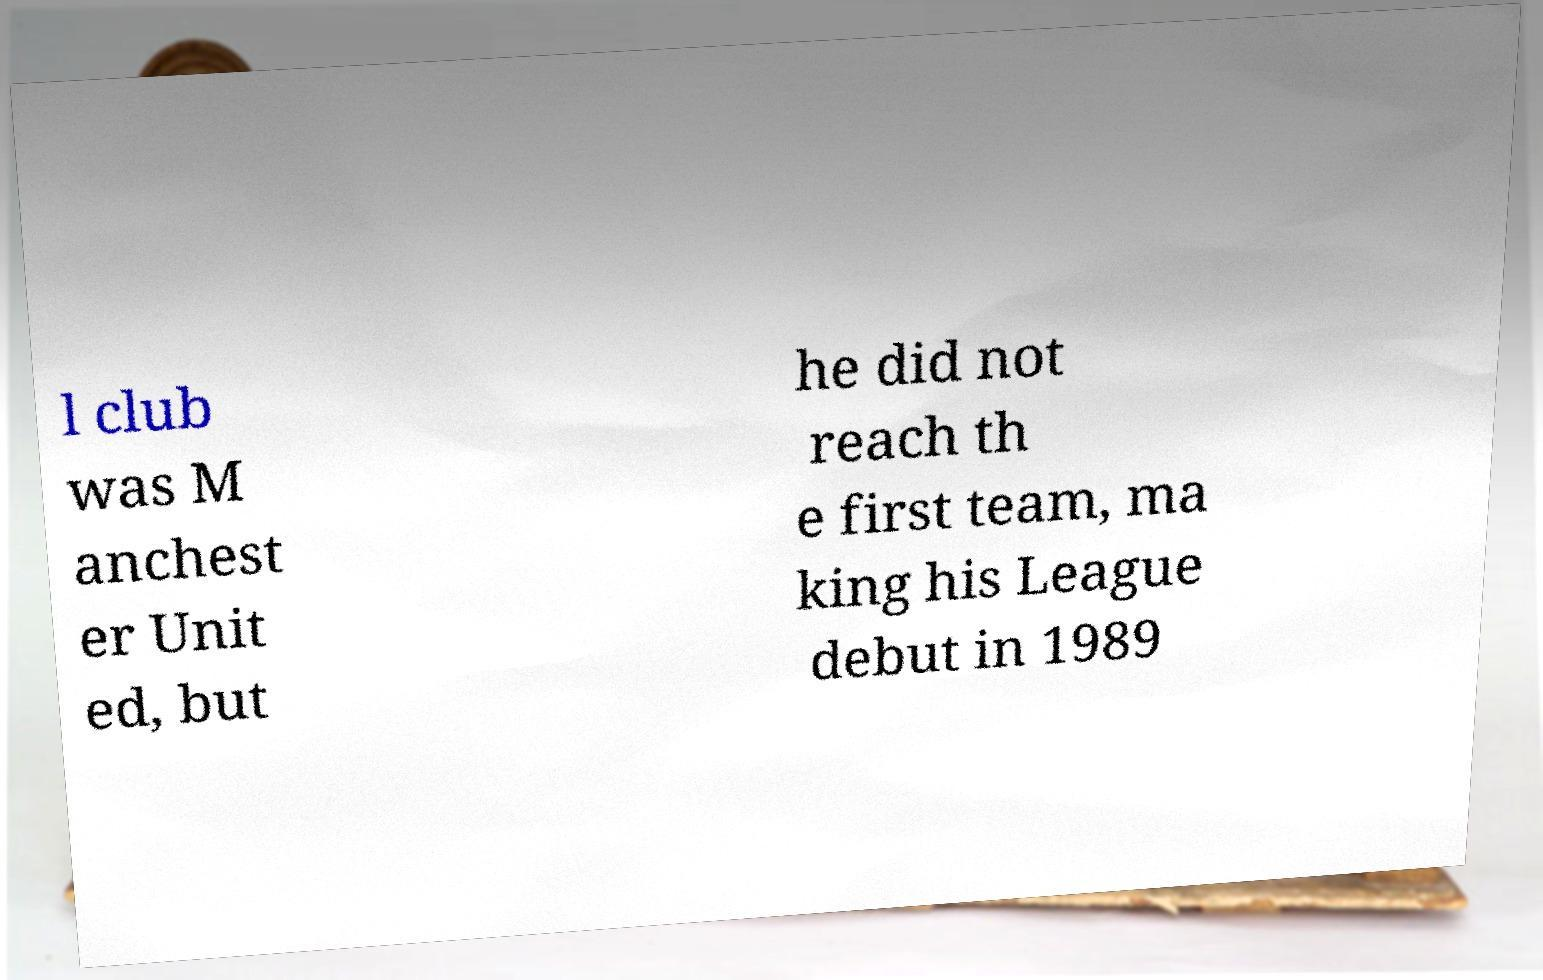What messages or text are displayed in this image? I need them in a readable, typed format. l club was M anchest er Unit ed, but he did not reach th e first team, ma king his League debut in 1989 